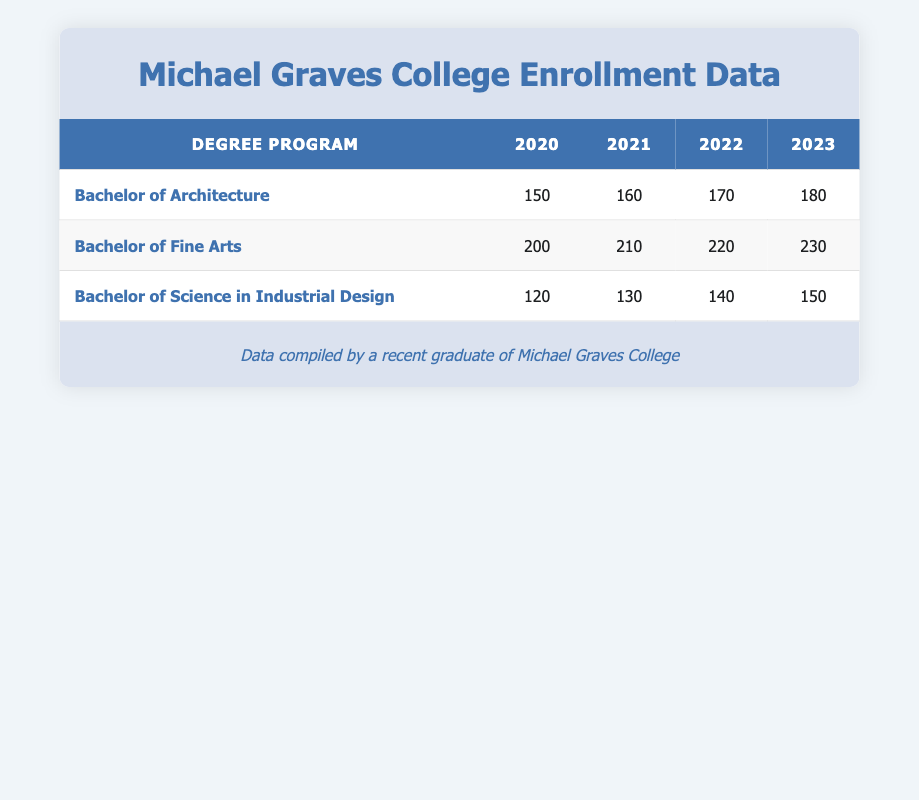What was the enrollment count for the Bachelor of Fine Arts in 2021? The table shows that for the Bachelor of Fine Arts in 2021, the enrollment count is listed directly under the year 2021 in the relevant row. So, the count is 210.
Answer: 210 Which degree program had the highest enrollment in 2022? By looking at the enrollment counts for each program in 2022, Bachelor of Fine Arts has 220, Bachelor of Architecture has 170, and Bachelor of Science in Industrial Design has 140. The highest count is therefore 220 for Bachelor of Fine Arts.
Answer: Bachelor of Fine Arts How much did the enrollment for the Bachelor of Architecture increase from 2020 to 2023? The enrollment in 2020 was 150, and in 2023 it is 180. To find the increase, subtract the 2020 count from the 2023 count: 180 - 150 = 30.
Answer: 30 Is it true that the enrollment for Bachelor of Science in Industrial Design decreased from 2021 to 2022? The enrollment for Bachelor of Science in Industrial Design in 2021 was 130, and in 2022 it was 140. Since 140 is greater than 130, the enrollment did not decrease; it increased.
Answer: No What is the total enrollment for all degree programs in 2023? To find the total enrollment for 2023, we sum the counts for each program: 180 (Bachelor of Architecture) + 230 (Bachelor of Fine Arts) + 150 (Bachelor of Science in Industrial Design) = 560.
Answer: 560 What was the average enrollment count for Bachelor of Fine Arts over the four years? The enrollment counts for Bachelor of Fine Arts are 200, 210, 220, and 230 for the years 2020 to 2023. To find the average, we sum these counts: 200 + 210 + 220 + 230 = 860, and then divide by 4 (the number of years): 860 / 4 = 215.
Answer: 215 Did the Bachelor of Science in Industrial Design have a higher enrollment in 2023 compared to 2020? The enrollment for Bachelor of Science in Industrial Design was 120 in 2020 and 150 in 2023. Since 150 is greater than 120, it had a higher enrollment in 2023 than in 2020.
Answer: Yes What is the percentage increase in enrollment for the Bachelor of Architecture from 2021 to 2022? The enrollment for Bachelor of Architecture in 2021 was 160 and in 2022 it was 170. The increase is 170 - 160 = 10. To find the percentage increase, we take the increase (10) divided by the original count (160) and multiply by 100. (10 / 160) * 100 = 6.25%.
Answer: 6.25% 